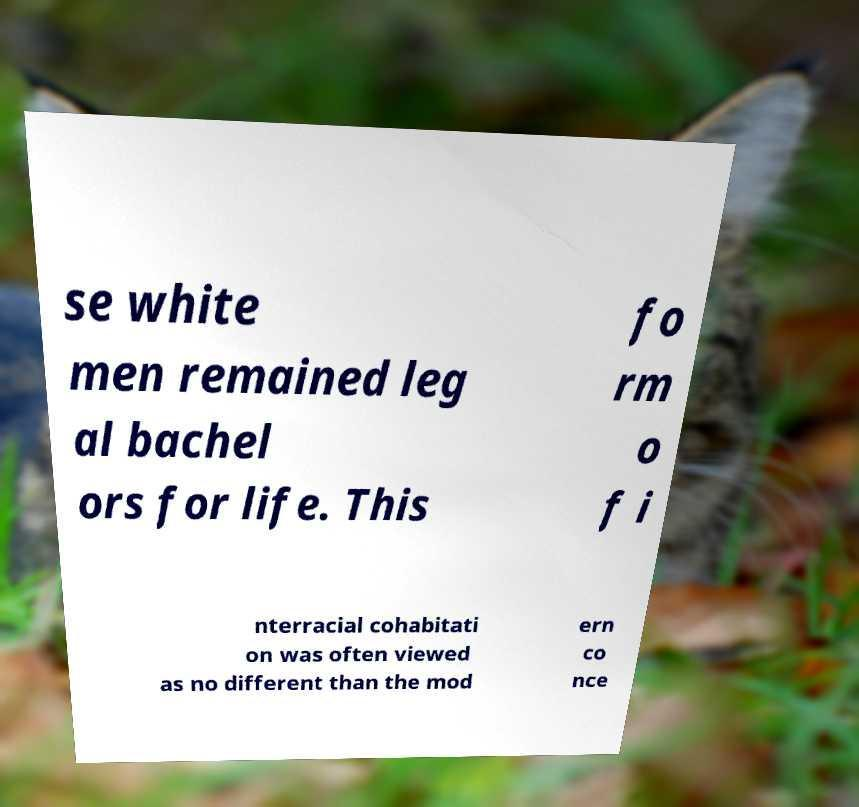For documentation purposes, I need the text within this image transcribed. Could you provide that? se white men remained leg al bachel ors for life. This fo rm o f i nterracial cohabitati on was often viewed as no different than the mod ern co nce 